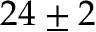<formula> <loc_0><loc_0><loc_500><loc_500>2 4 \pm 2</formula> 